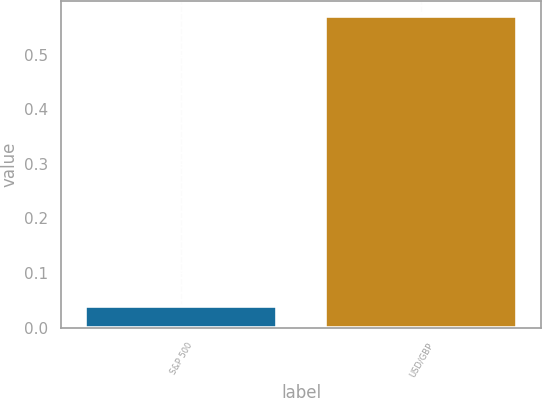Convert chart to OTSL. <chart><loc_0><loc_0><loc_500><loc_500><bar_chart><fcel>S&P 500<fcel>USD/GBP<nl><fcel>0.04<fcel>0.57<nl></chart> 